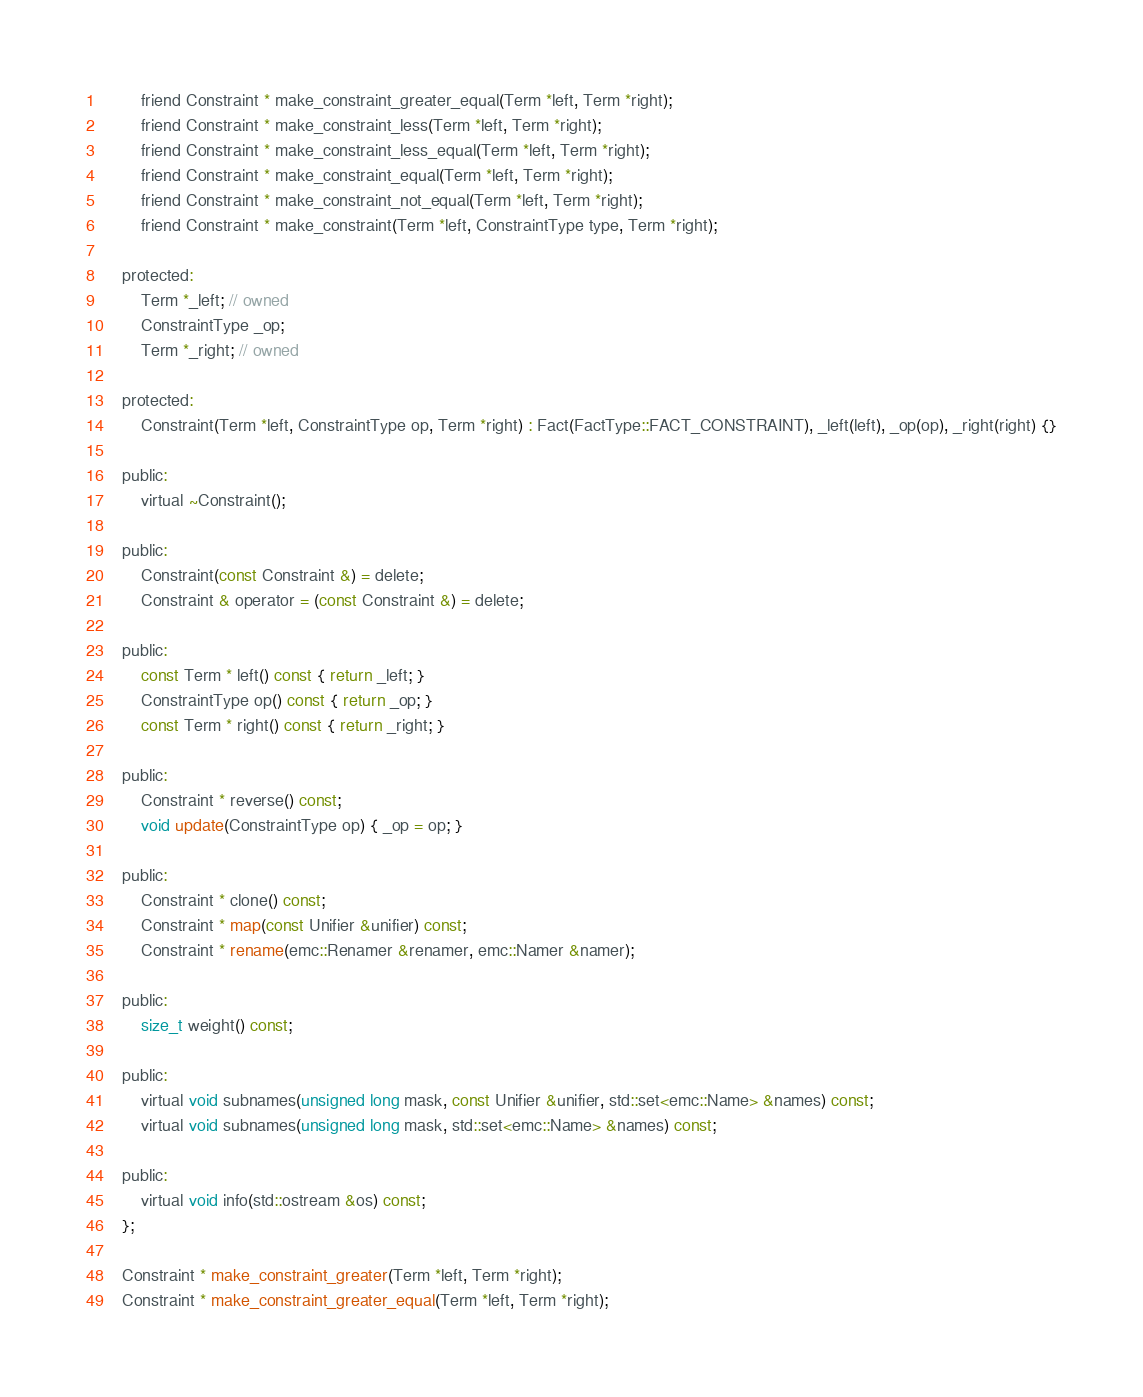Convert code to text. <code><loc_0><loc_0><loc_500><loc_500><_C_>        friend Constraint * make_constraint_greater_equal(Term *left, Term *right);
        friend Constraint * make_constraint_less(Term *left, Term *right);
        friend Constraint * make_constraint_less_equal(Term *left, Term *right);
        friend Constraint * make_constraint_equal(Term *left, Term *right);
        friend Constraint * make_constraint_not_equal(Term *left, Term *right);
        friend Constraint * make_constraint(Term *left, ConstraintType type, Term *right);
        
    protected:
        Term *_left; // owned
        ConstraintType _op;
        Term *_right; // owned
        
    protected:
        Constraint(Term *left, ConstraintType op, Term *right) : Fact(FactType::FACT_CONSTRAINT), _left(left), _op(op), _right(right) {}
        
    public:
        virtual ~Constraint();
        
    public:
        Constraint(const Constraint &) = delete;
        Constraint & operator = (const Constraint &) = delete;
        
    public:
        const Term * left() const { return _left; }
        ConstraintType op() const { return _op; }
        const Term * right() const { return _right; }
        
    public:
        Constraint * reverse() const;
        void update(ConstraintType op) { _op = op; }
        
    public:
        Constraint * clone() const;
        Constraint * map(const Unifier &unifier) const;
        Constraint * rename(emc::Renamer &renamer, emc::Namer &namer);
        
    public:
        size_t weight() const;
        
    public:
        virtual void subnames(unsigned long mask, const Unifier &unifier, std::set<emc::Name> &names) const;
        virtual void subnames(unsigned long mask, std::set<emc::Name> &names) const;
        
    public:
        virtual void info(std::ostream &os) const;
    };
    
    Constraint * make_constraint_greater(Term *left, Term *right);
    Constraint * make_constraint_greater_equal(Term *left, Term *right);</code> 